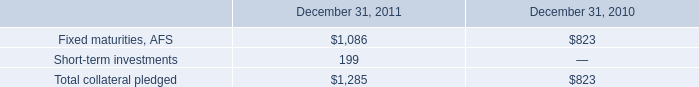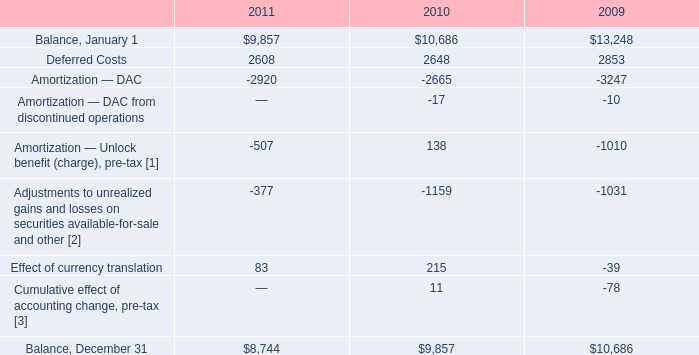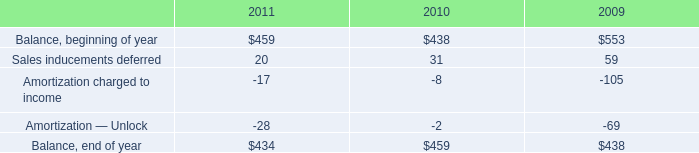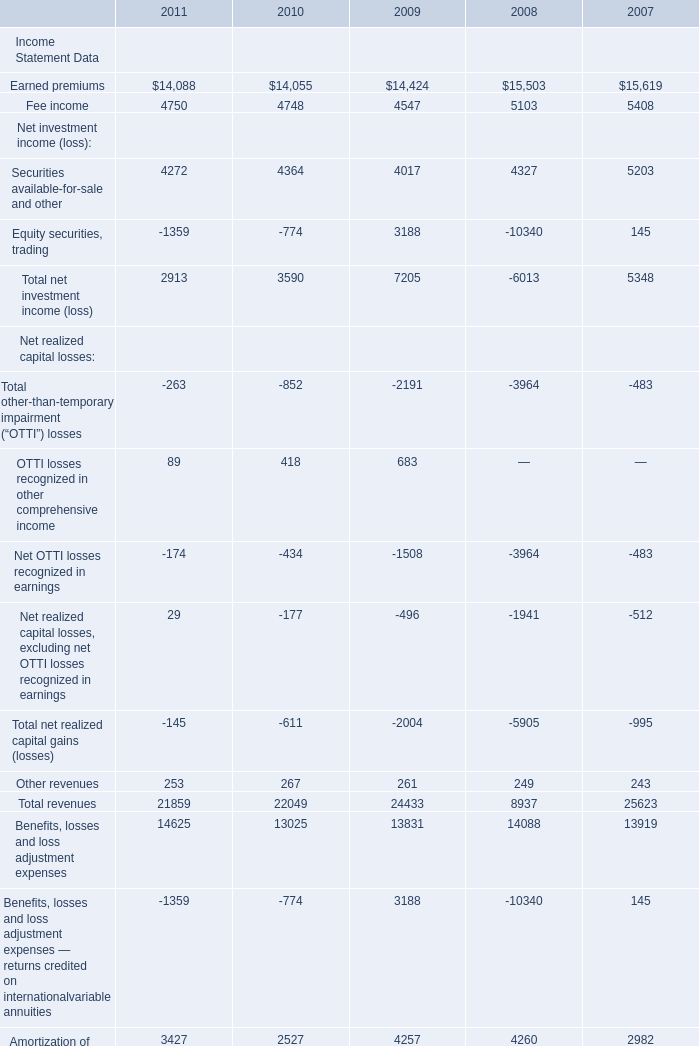What's the average of Amortization — DAC of 2011, and Earned premiums of 2007 ? 
Computations: ((2920.0 + 15619.0) / 2)
Answer: 9269.5. 